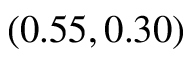Convert formula to latex. <formula><loc_0><loc_0><loc_500><loc_500>( 0 . 5 5 , 0 . 3 0 )</formula> 